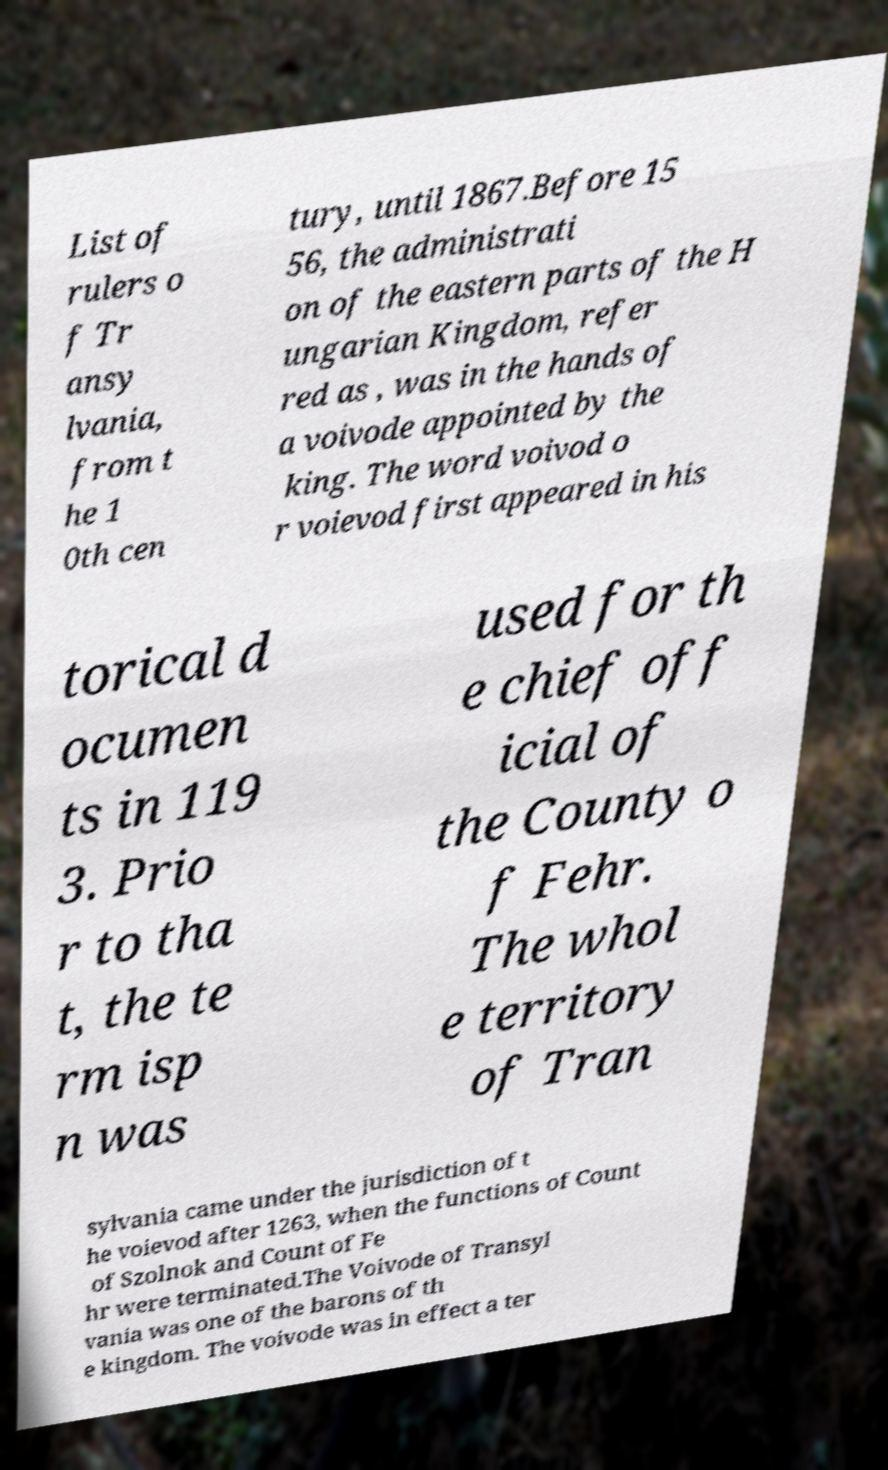Can you accurately transcribe the text from the provided image for me? List of rulers o f Tr ansy lvania, from t he 1 0th cen tury, until 1867.Before 15 56, the administrati on of the eastern parts of the H ungarian Kingdom, refer red as , was in the hands of a voivode appointed by the king. The word voivod o r voievod first appeared in his torical d ocumen ts in 119 3. Prio r to tha t, the te rm isp n was used for th e chief off icial of the County o f Fehr. The whol e territory of Tran sylvania came under the jurisdiction of t he voievod after 1263, when the functions of Count of Szolnok and Count of Fe hr were terminated.The Voivode of Transyl vania was one of the barons of th e kingdom. The voivode was in effect a ter 